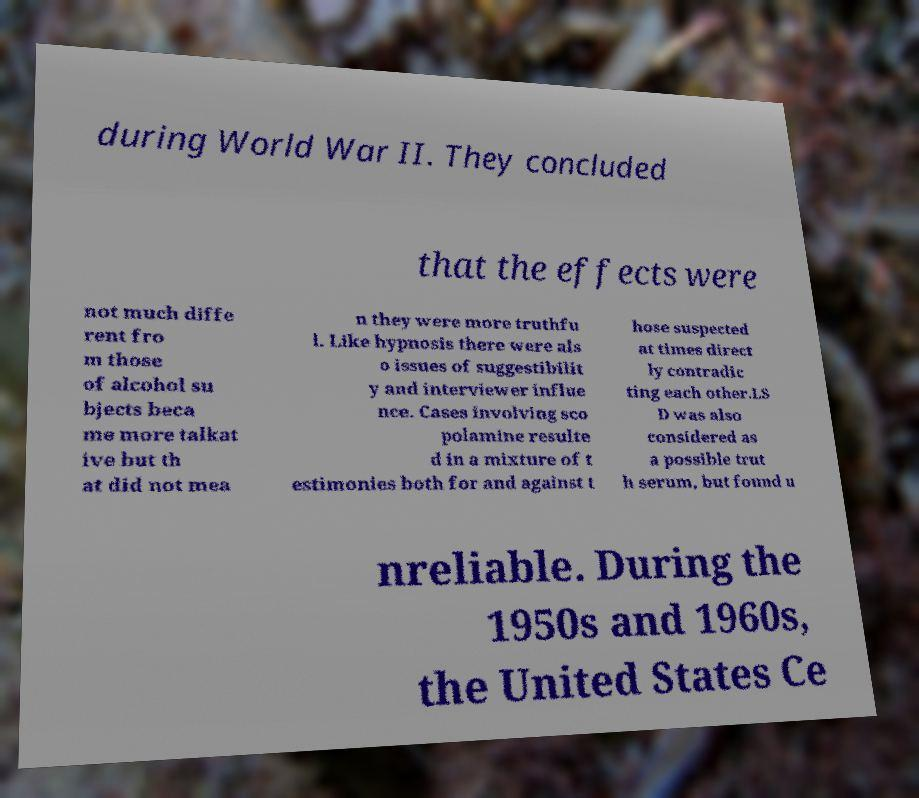Could you extract and type out the text from this image? during World War II. They concluded that the effects were not much diffe rent fro m those of alcohol su bjects beca me more talkat ive but th at did not mea n they were more truthfu l. Like hypnosis there were als o issues of suggestibilit y and interviewer influe nce. Cases involving sco polamine resulte d in a mixture of t estimonies both for and against t hose suspected at times direct ly contradic ting each other.LS D was also considered as a possible trut h serum, but found u nreliable. During the 1950s and 1960s, the United States Ce 